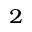Convert formula to latex. <formula><loc_0><loc_0><loc_500><loc_500>^ { 2 }</formula> 